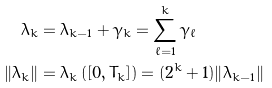<formula> <loc_0><loc_0><loc_500><loc_500>\lambda _ { k } & = \lambda _ { k - 1 } + \gamma _ { k } = \sum _ { \ell = 1 } ^ { k } \gamma _ { \ell } \\ \| \lambda _ { k } \| & = \lambda _ { k } \left ( [ 0 , T _ { k } ] \right ) = ( 2 ^ { k } + 1 ) \| \lambda _ { k - 1 } \|</formula> 